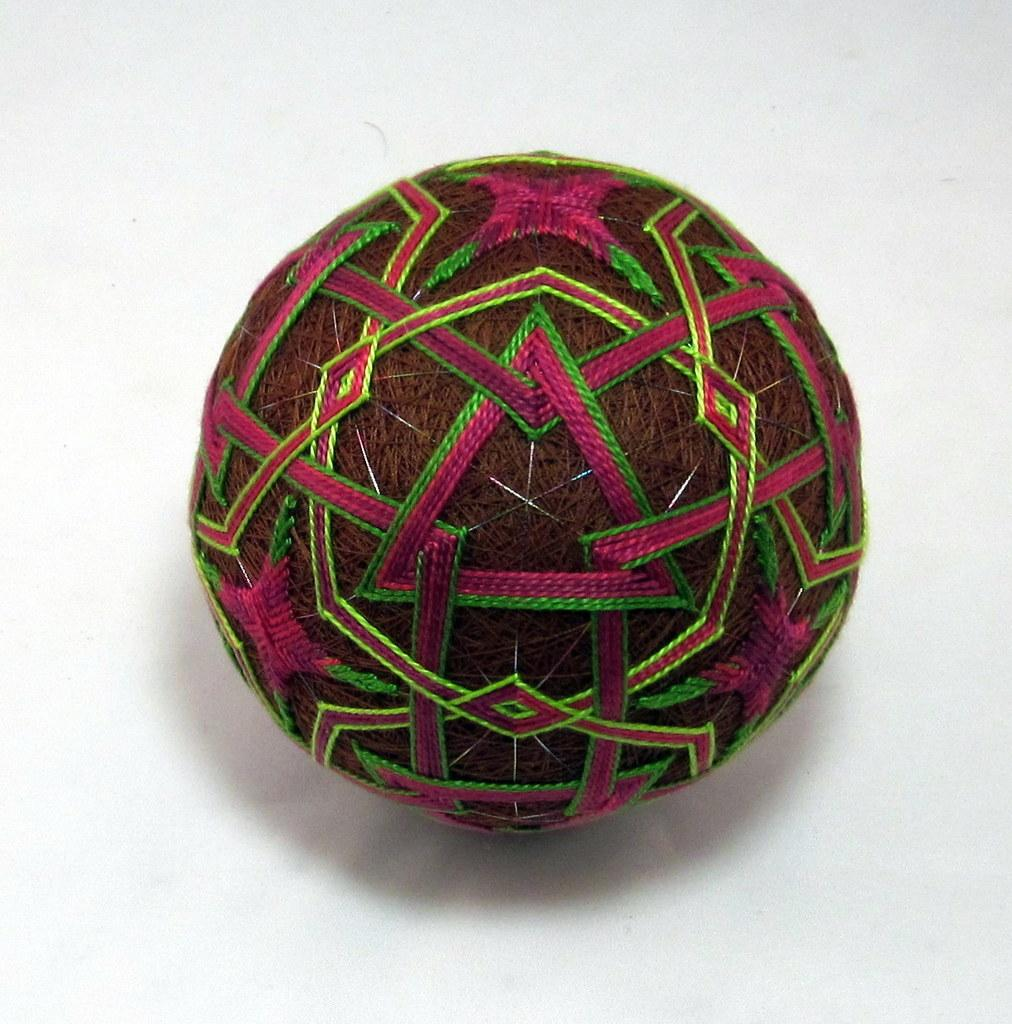What object can be seen in the image? There is a ball in the image. What is the ball made of? The ball is made of threads. Where is the ball located? The ball is placed on a white platform. How many pins are holding the ball in place on the bridge in the image? There is no bridge or pins present in the image; it features a ball made of threads placed on a white platform. 